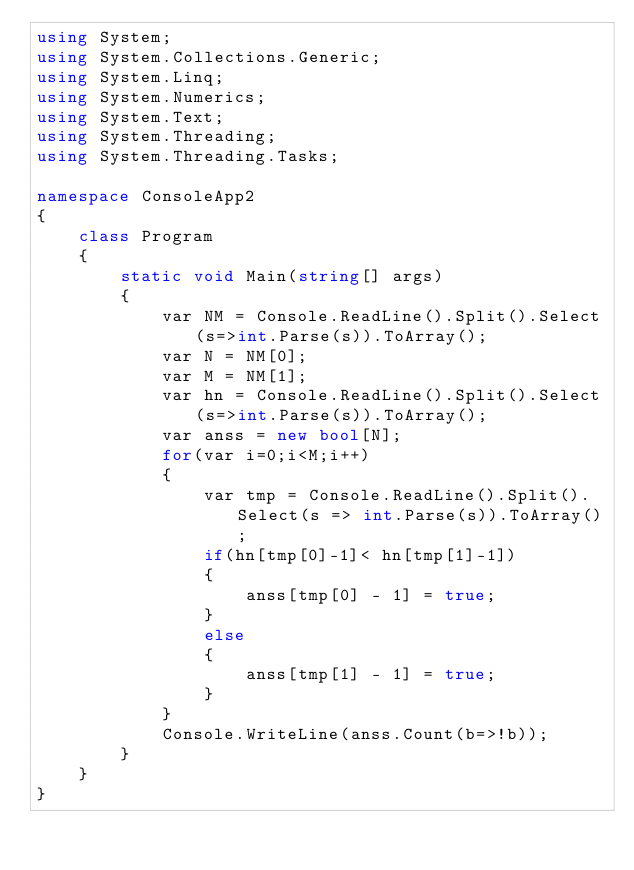<code> <loc_0><loc_0><loc_500><loc_500><_C#_>using System;
using System.Collections.Generic;
using System.Linq;
using System.Numerics;
using System.Text;
using System.Threading;
using System.Threading.Tasks;

namespace ConsoleApp2
{
    class Program
    {
        static void Main(string[] args)
        {
            var NM = Console.ReadLine().Split().Select(s=>int.Parse(s)).ToArray();
            var N = NM[0];
            var M = NM[1];
            var hn = Console.ReadLine().Split().Select(s=>int.Parse(s)).ToArray();
            var anss = new bool[N];
            for(var i=0;i<M;i++)
            {
                var tmp = Console.ReadLine().Split().Select(s => int.Parse(s)).ToArray();
                if(hn[tmp[0]-1]< hn[tmp[1]-1])
                {
                    anss[tmp[0] - 1] = true;
                }
                else
                {
                    anss[tmp[1] - 1] = true;
                }
            }
            Console.WriteLine(anss.Count(b=>!b));
        }
    }
}</code> 